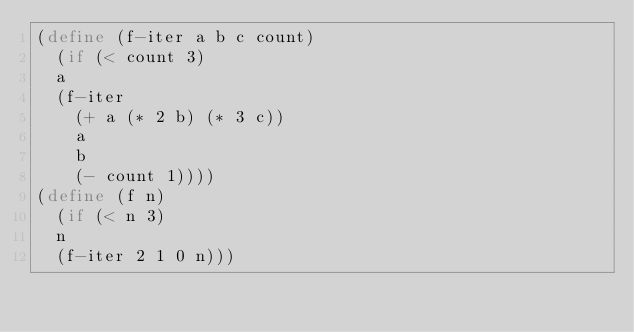Convert code to text. <code><loc_0><loc_0><loc_500><loc_500><_Scheme_>(define (f-iter a b c count)
  (if (< count 3)
	a
	(f-iter
	  (+ a (* 2 b) (* 3 c))
	  a
	  b
	  (- count 1))))
(define (f n)
  (if (< n 3)
	n
	(f-iter 2 1 0 n)))
</code> 